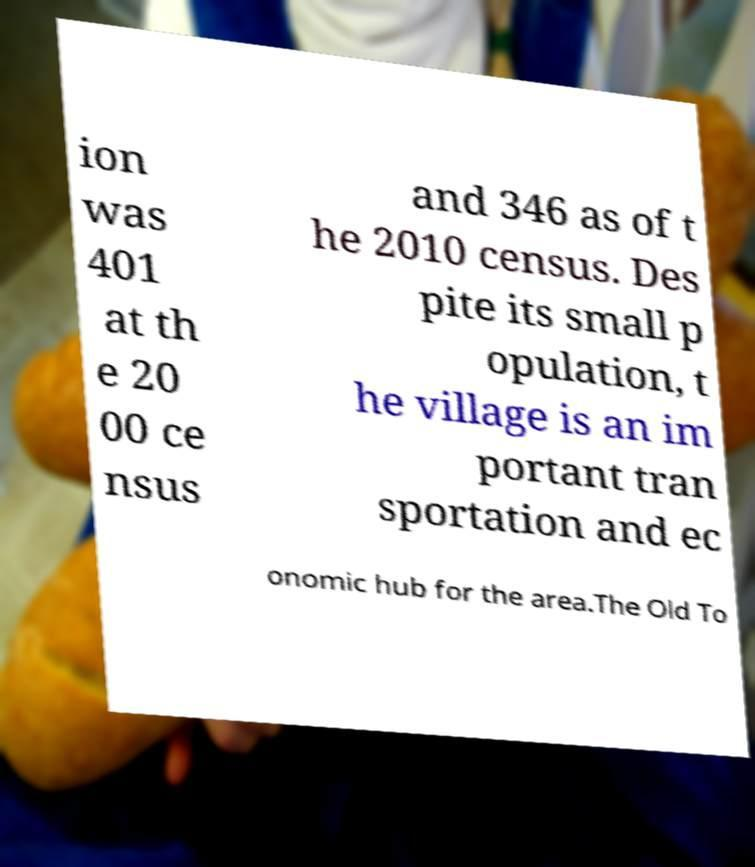Please identify and transcribe the text found in this image. ion was 401 at th e 20 00 ce nsus and 346 as of t he 2010 census. Des pite its small p opulation, t he village is an im portant tran sportation and ec onomic hub for the area.The Old To 